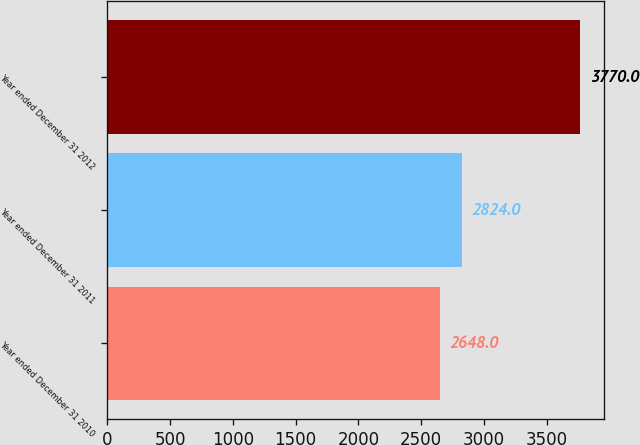<chart> <loc_0><loc_0><loc_500><loc_500><bar_chart><fcel>Year ended December 31 2010<fcel>Year ended December 31 2011<fcel>Year ended December 31 2012<nl><fcel>2648<fcel>2824<fcel>3770<nl></chart> 